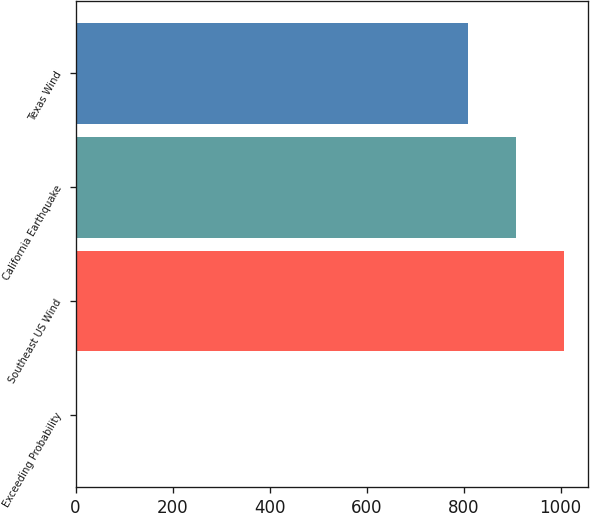<chart> <loc_0><loc_0><loc_500><loc_500><bar_chart><fcel>Exceeding Probability<fcel>Southeast US Wind<fcel>California Earthquake<fcel>Texas Wind<nl><fcel>0.4<fcel>1006.12<fcel>907.56<fcel>809<nl></chart> 